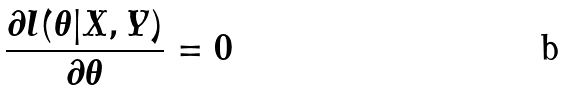<formula> <loc_0><loc_0><loc_500><loc_500>\frac { \partial l ( \theta | X , Y ) } { \partial \theta } = 0</formula> 